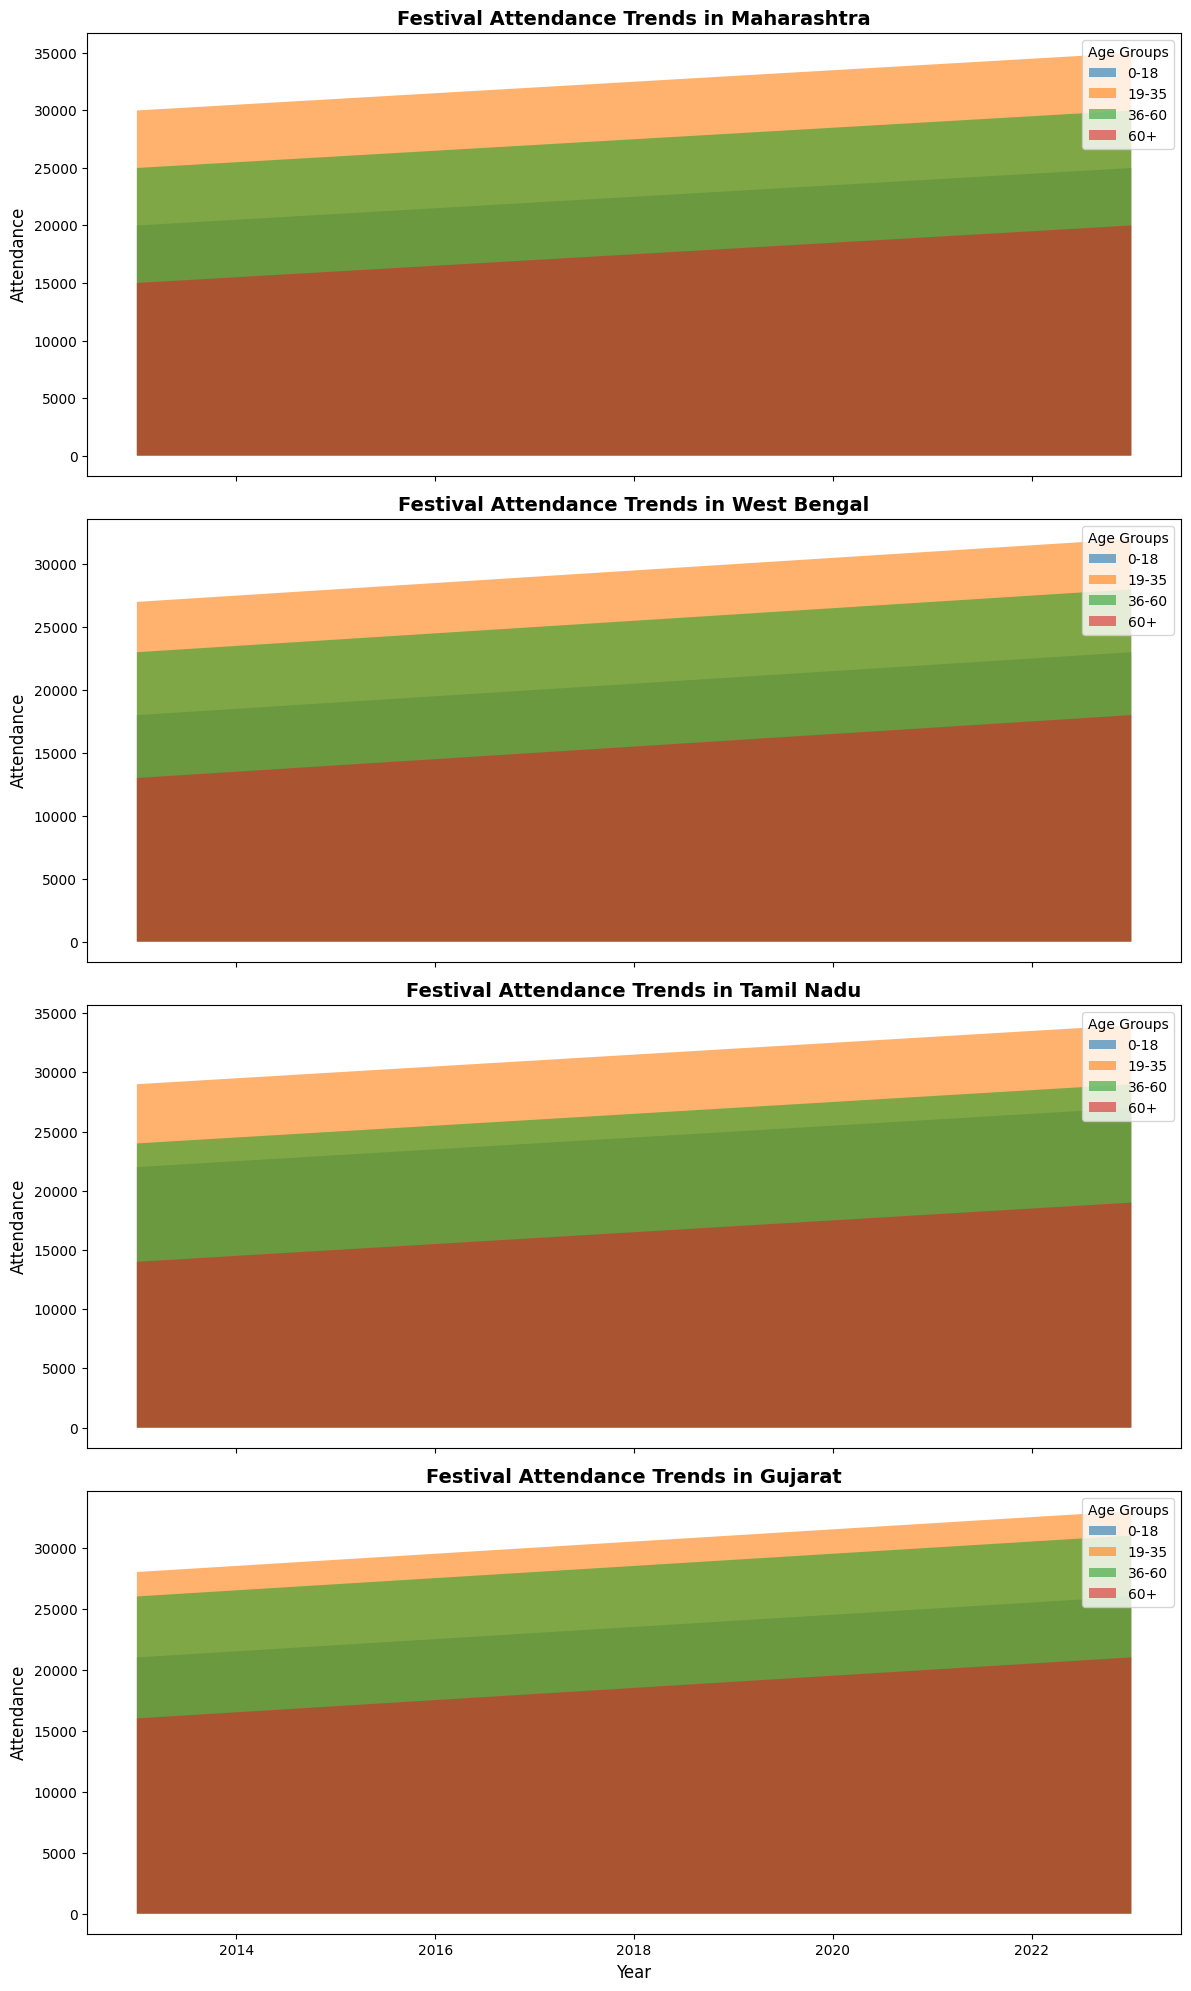Which age group had the highest attendance in Maharashtra in 2021? Look at the area chart for Maharashtra in 2021 and compare the heights of the filled areas corresponding to each age group. The highest filled area corresponds to the 19-35 age group.
Answer: 19-35 How did the attendance for the age group 60+ in Gujarat change from 2013 to 2023? Observe the trend of the filled area for the 60+ age group in Gujarat from 2013 to 2023. There is an increase in the attendance from 16000 in 2013 to 21000 in 2023.
Answer: Increased Compare the total attendance in Tamil Nadu for the 36-60 age group between 2015 and 2023. Look at the heights of the filled areas for the age group 36-60 in Tamil Nadu for the years 2015 and 2023. The total attendance in 2015 is 25000, and in 2023 it is 29000.
Answer: Attendance increased by 4000 Which state had the lowest attendance in the 0-18 age group in 2013? Compare the heights of the filled areas for the 0-18 age group across all states in 2013. West Bengal had the lowest attendance with 18000.
Answer: West Bengal What is the average attendance of the 19-35 age group across all states in 2023? Identify the attendance numbers for the 19-35 age group in each state in 2023, add them up, and divide by the number of states. The attendances are 35000 (Maharashtra), 32000 (West Bengal), 34000 (Tamil Nadu), 33000 (Gujarat). Total is 134000 and the average is 134000/4.
Answer: 33500 